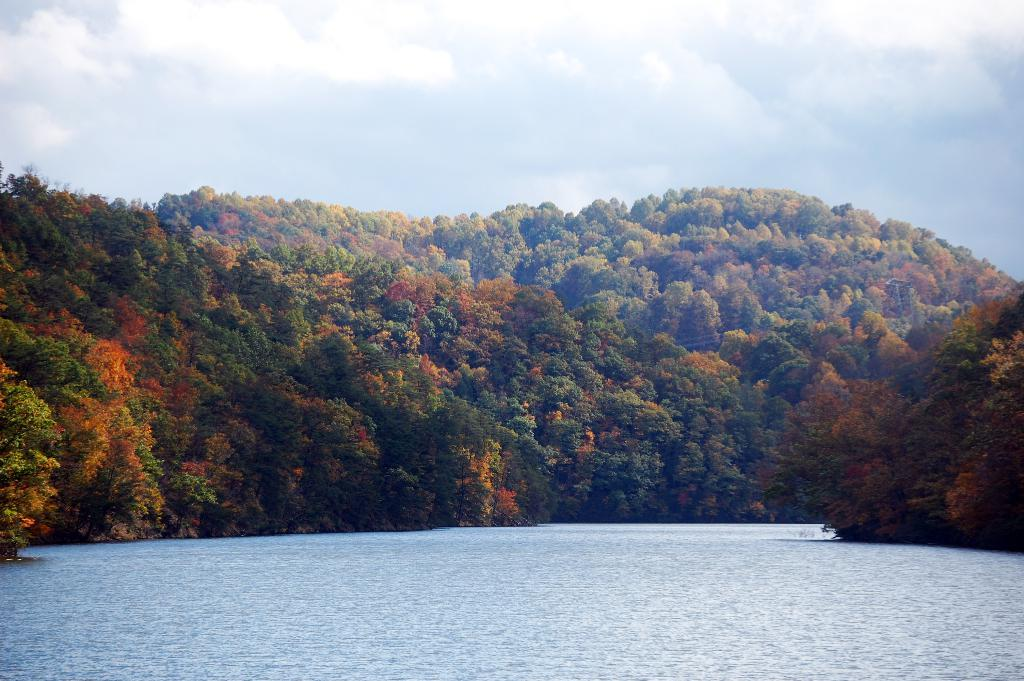What type of vegetation can be seen in the image? There are trees in the image. What natural feature is present in the image? There is a river in the image. What is visible in the background of the image? The sky is visible in the image. What type of teeth can be seen in the image? There are no teeth visible in the image. What offer is being made in the image? There is no offer being made in the image. 